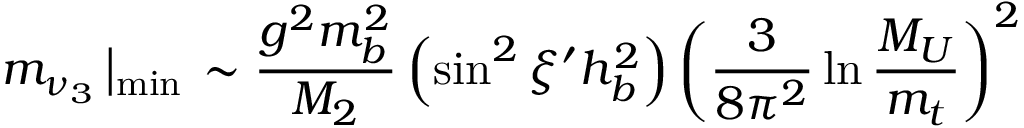Convert formula to latex. <formula><loc_0><loc_0><loc_500><loc_500>m _ { \nu _ { 3 } } \left | _ { \min } \sim \frac { g ^ { 2 } m _ { b } ^ { 2 } } { M _ { 2 } } \left ( \sin ^ { 2 } \xi ^ { \prime } h _ { b } ^ { 2 } \right ) \left ( \frac { 3 } 8 \pi ^ { 2 } } \ln \frac { M _ { U } } { m _ { t } } \right ) ^ { 2 }</formula> 